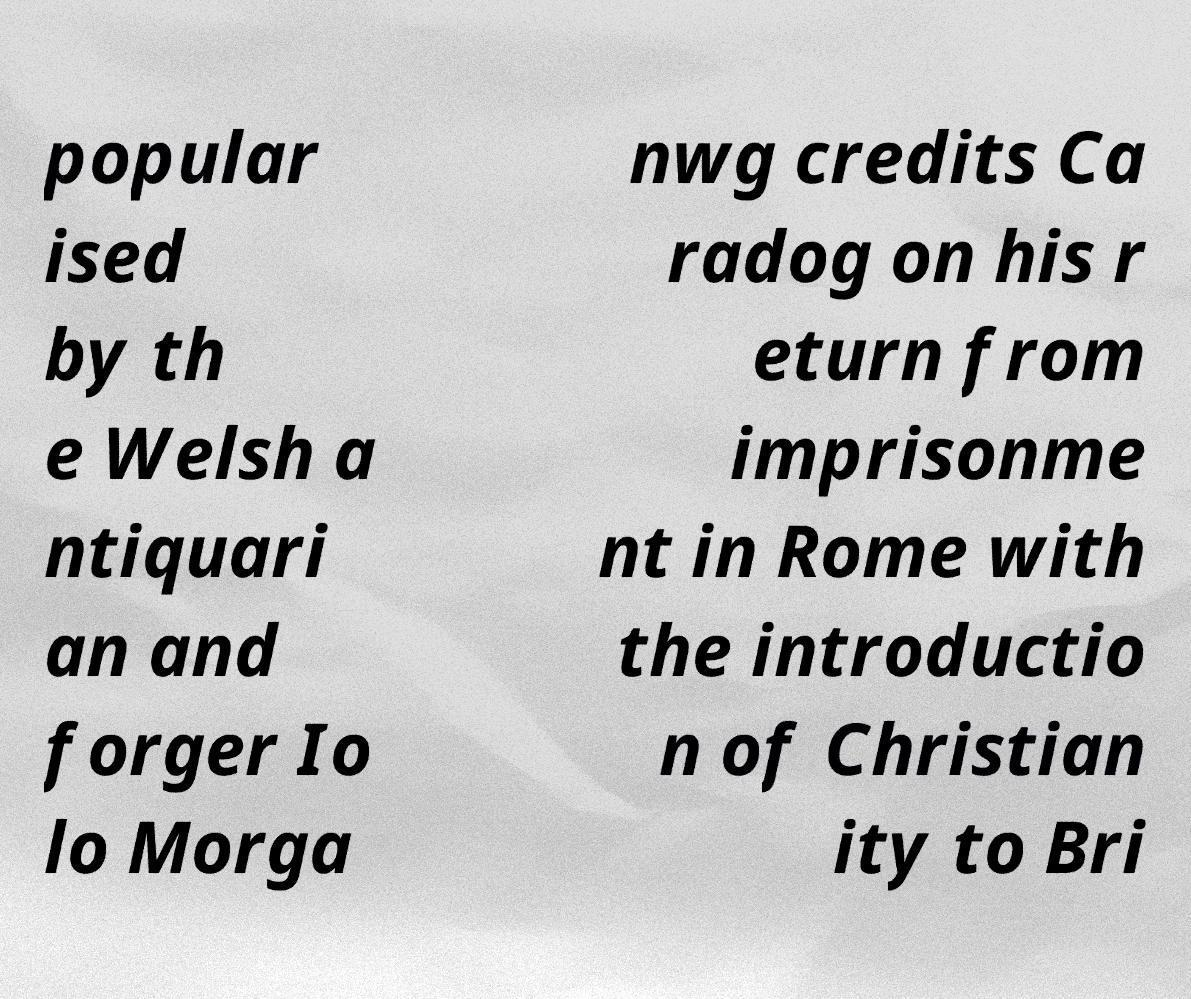I need the written content from this picture converted into text. Can you do that? popular ised by th e Welsh a ntiquari an and forger Io lo Morga nwg credits Ca radog on his r eturn from imprisonme nt in Rome with the introductio n of Christian ity to Bri 